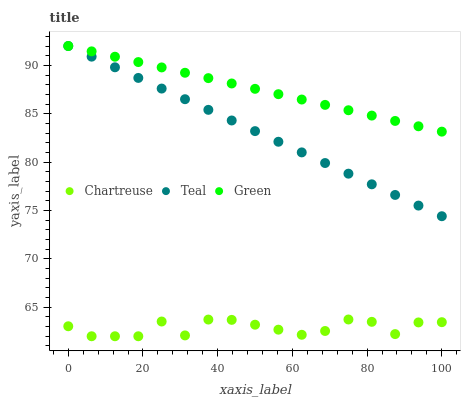Does Chartreuse have the minimum area under the curve?
Answer yes or no. Yes. Does Green have the maximum area under the curve?
Answer yes or no. Yes. Does Teal have the minimum area under the curve?
Answer yes or no. No. Does Teal have the maximum area under the curve?
Answer yes or no. No. Is Teal the smoothest?
Answer yes or no. Yes. Is Chartreuse the roughest?
Answer yes or no. Yes. Is Green the smoothest?
Answer yes or no. No. Is Green the roughest?
Answer yes or no. No. Does Chartreuse have the lowest value?
Answer yes or no. Yes. Does Teal have the lowest value?
Answer yes or no. No. Does Teal have the highest value?
Answer yes or no. Yes. Is Chartreuse less than Green?
Answer yes or no. Yes. Is Teal greater than Chartreuse?
Answer yes or no. Yes. Does Green intersect Teal?
Answer yes or no. Yes. Is Green less than Teal?
Answer yes or no. No. Is Green greater than Teal?
Answer yes or no. No. Does Chartreuse intersect Green?
Answer yes or no. No. 